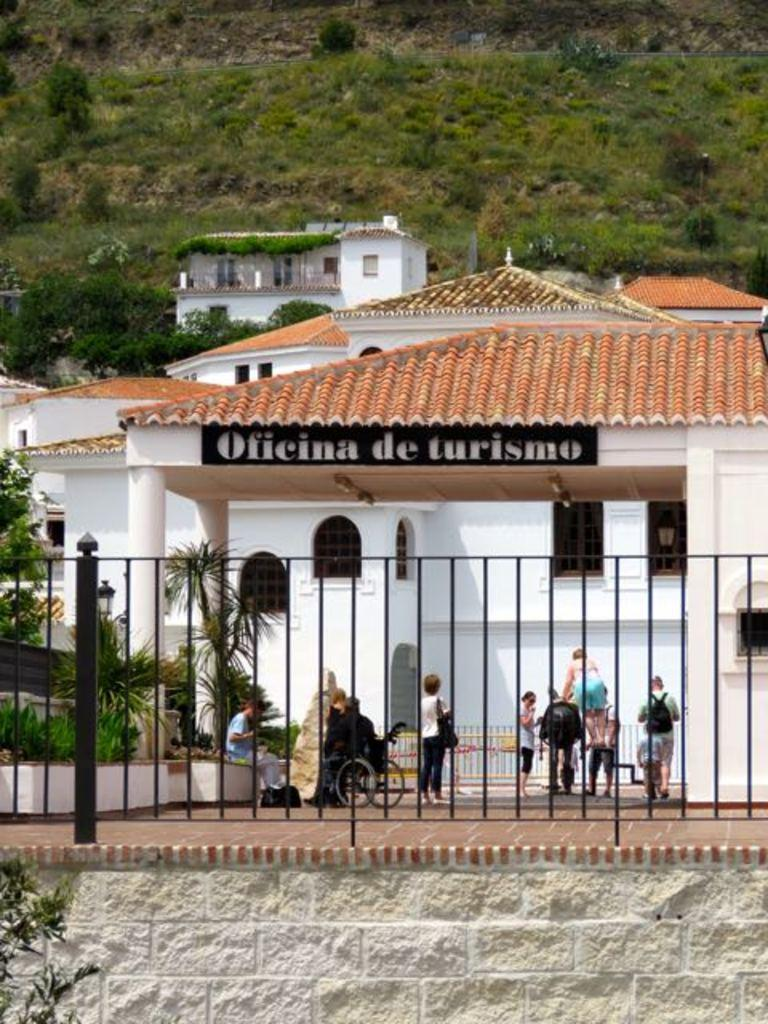What type of structure can be seen in the image? There is a fence in the image. Can you describe the people in the image? There are persons in the image. What can be seen in the distance behind the fence? There are buildings and trees in the background of the image. How many attempts did the ground make to jump over the fence in the image? The ground does not make attempts to jump over the fence, as it is an inanimate object and cannot perform actions like jumping. 